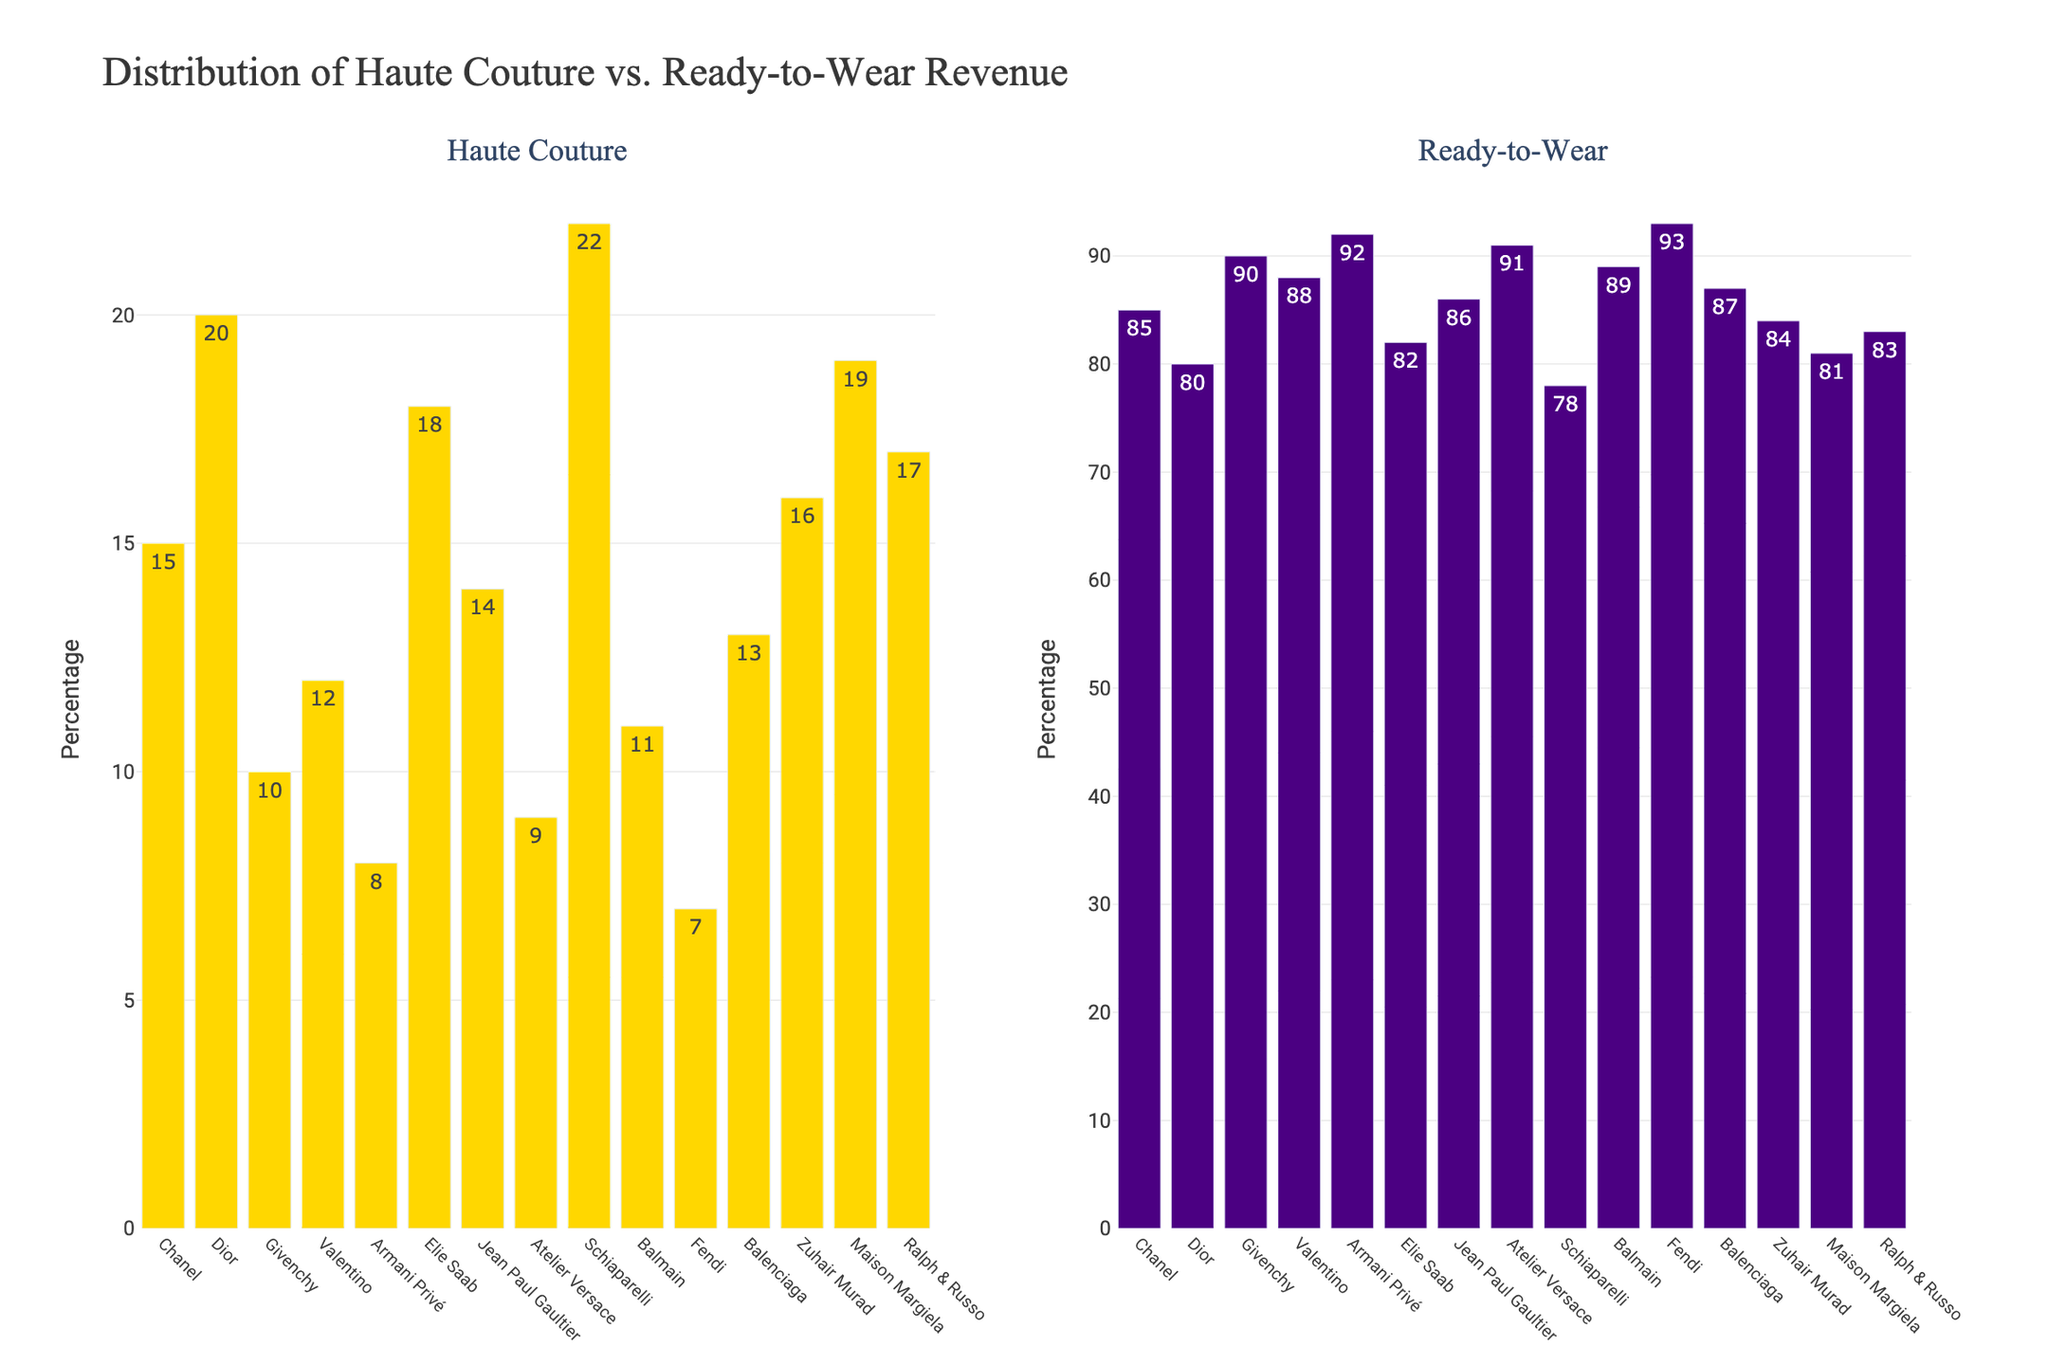what is the percentage difference in haute couture revenue between Fendi and Schiaparelli? To find the percentage difference, subtract Fendi's haute couture percentage (7%) from Schiaparelli's haute couture percentage (22%): 22% - 7% = 15%
Answer: 15% Which fashion house has the highest percentage of revenue from ready-to-wear collections? By looking at the heights of the bars in the ready-to-wear subplot, Fendi has the highest percentage with 93%.
Answer: Fendi What is the total percentage of haute couture revenue for Chanel, Dior, and Givenchy combined? Add the haute couture percentages for Chanel (15%), Dior (20%), and Givenchy (10%): 15% + 20% + 10% = 45%
Answer: 45% How does the percentage of haute couture revenue for Balenciaga compare with Maison Margiela? Compare the heights of the haute couture bars for Balenciaga (13%) and Maison Margiela (19%): Balenciaga's percentage is lower.
Answer: Lower What is the average percentage of revenue from haute couture for all the fashion houses? Sum all haute couture percentages: 15 + 20 + 10 + 12 + 8 + 18 + 14 + 9 + 22 + 11 + 7 + 13 + 16 + 19 + 17 = 201. Divide by the number of fashion houses (15): 201 / 15 = 13.4%
Answer: 13.4% Which two fashion houses have a combined haute couture revenue percentage equal to that of Schiaparelli? Schiaparelli has 22% haute couture revenue. 15% from Chanel + 7% from Fendi = 22%
Answer: Chanel and Fendi Between Elie Saab and Ralph & Russo, which fashion house has a higher percentage of revenue from haute couture? Compare the heights of the haute couture bars for Elie Saab (18%) and Ralph & Russo (17%): Elie Saab's percentage is higher.
Answer: Elie Saab What is the total percentage of ready-to-wear revenue for Elie Saab and Jean Paul Gaultier combined? Add the ready-to-wear percentages for Elie Saab (82%) and Jean Paul Gaultier (86%): 82% + 86% = 168%
Answer: 168% Is the ready-to-wear revenue percentage for Valentino higher or lower than the average ready-to-wear revenue percentage? Valentino's ready-to-wear percentage is 88%. The average is 100% - 13.4% = 86.6%. Compare the two: 88% is higher than 86.6%.
Answer: Higher 